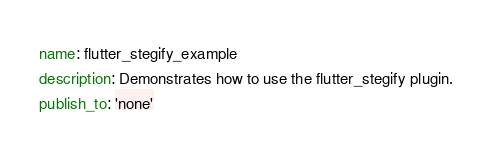<code> <loc_0><loc_0><loc_500><loc_500><_YAML_>name: flutter_stegify_example
description: Demonstrates how to use the flutter_stegify plugin.
publish_to: 'none'
</code> 